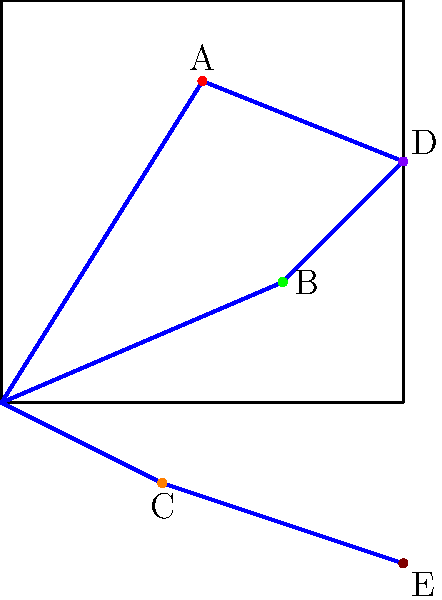Based on the geographical distribution chart of textile artifacts, which route appears to be the most significant for the trade of multiple textile types, and what does this imply about the historical importance of the locations along this path? To answer this question, we need to analyze the given geographical distribution chart:

1. Identify the routes:
   - Northern route: (0,0) to A to D
   - Central route: (0,0) to B to D
   - Southern route: (0,0) to C to E

2. Analyze textile distribution:
   - Point A: Red textile
   - Point B: Green textile
   - Point C: Orange textile
   - Point D: Purple textile
   - Point E: Brown textile

3. Evaluate route significance:
   - Northern route: Connects red (A) and purple (D) textiles
   - Central route: Connects green (B) and purple (D) textiles
   - Southern route: Connects orange (C) and brown (E) textiles

4. Determine the most significant route:
   The central route (0,0) to B to D is the most significant because:
   a. It connects three different textile types (origin, green, and purple)
   b. It intersects with the northern route at point D, potentially facilitating trade between red, green, and purple textiles

5. Implications for historical importance:
   a. The locations along the central route likely served as major trading hubs
   b. Point D appears to be a crucial intersection, possibly a large market or port city
   c. The diversity of textiles along this route suggests it was a well-established and frequently used trade path
   d. The societies along this route may have been more economically and culturally diverse due to the variety of goods traded
Answer: Central route; major trading hubs and cultural exchange centers 